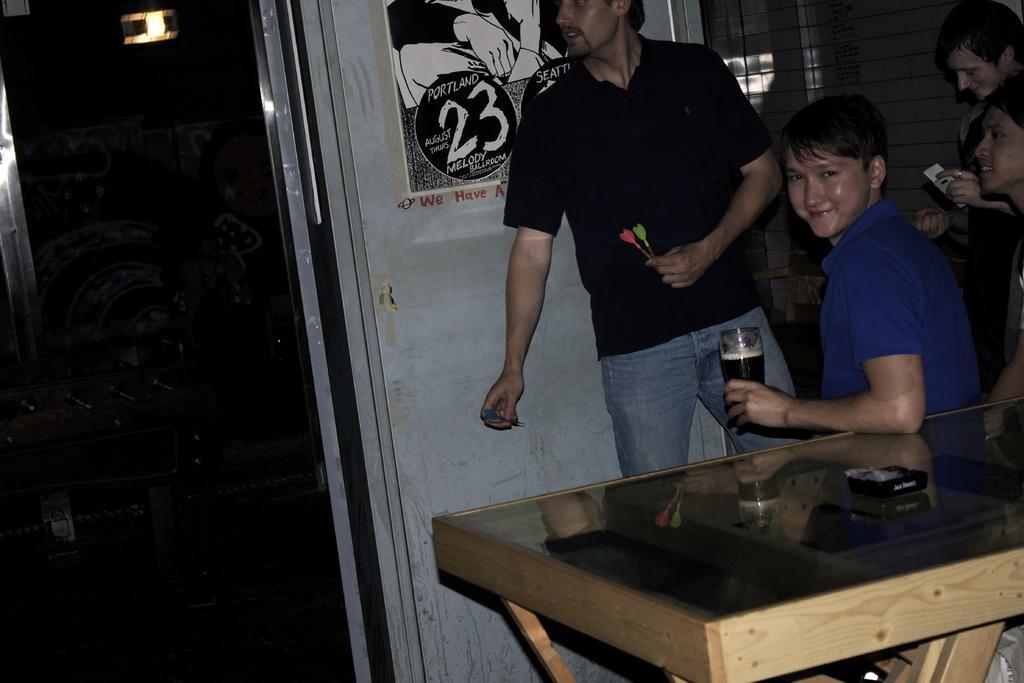In one or two sentences, can you explain what this image depicts? In the image there are two people sitting on chair in front of a table and other two people are standing, in background there is a white color wall,window and a poster. 